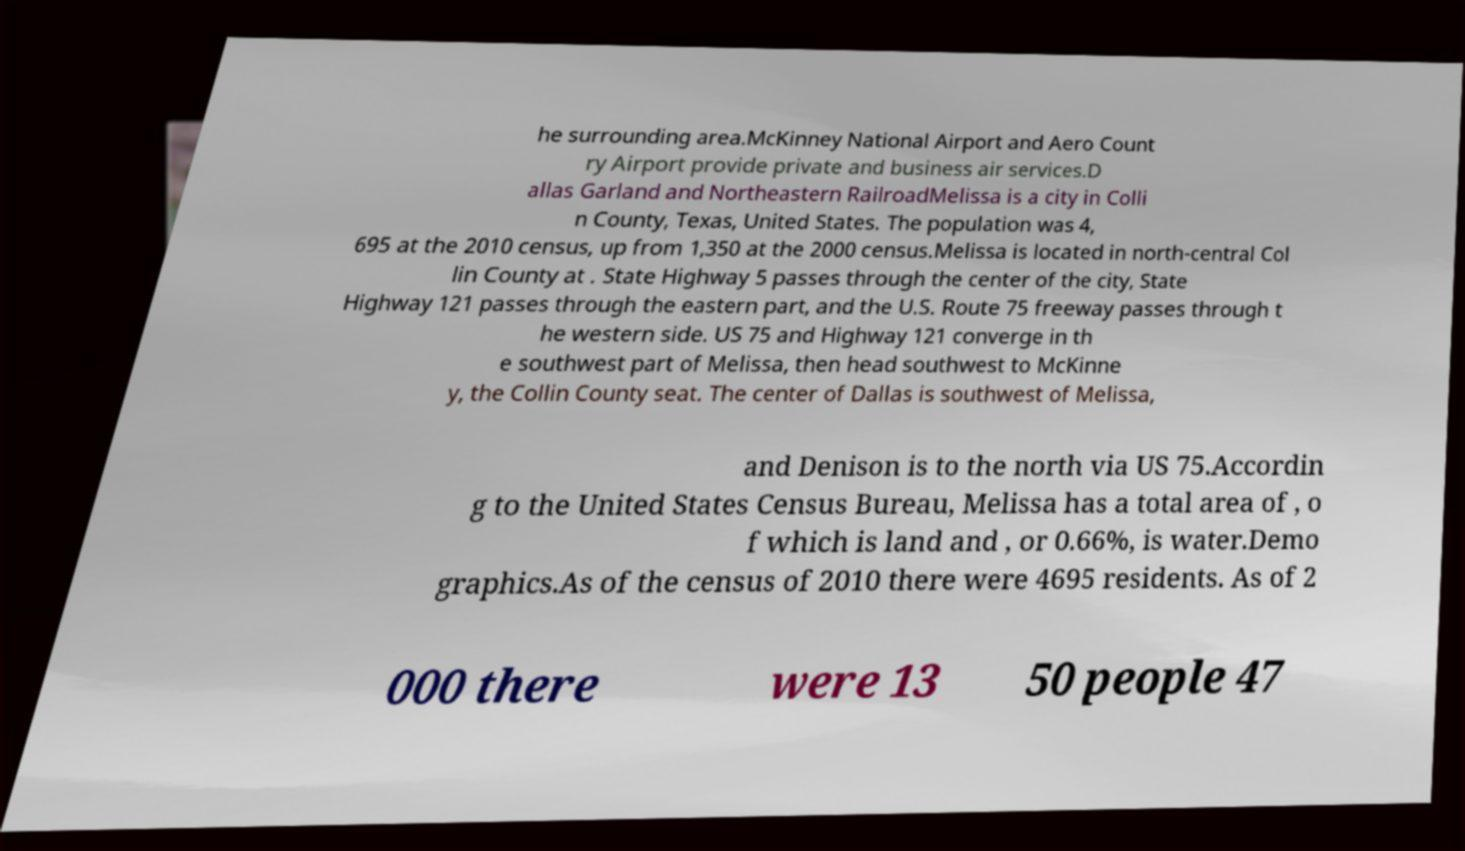Please read and relay the text visible in this image. What does it say? he surrounding area.McKinney National Airport and Aero Count ry Airport provide private and business air services.D allas Garland and Northeastern RailroadMelissa is a city in Colli n County, Texas, United States. The population was 4, 695 at the 2010 census, up from 1,350 at the 2000 census.Melissa is located in north-central Col lin County at . State Highway 5 passes through the center of the city, State Highway 121 passes through the eastern part, and the U.S. Route 75 freeway passes through t he western side. US 75 and Highway 121 converge in th e southwest part of Melissa, then head southwest to McKinne y, the Collin County seat. The center of Dallas is southwest of Melissa, and Denison is to the north via US 75.Accordin g to the United States Census Bureau, Melissa has a total area of , o f which is land and , or 0.66%, is water.Demo graphics.As of the census of 2010 there were 4695 residents. As of 2 000 there were 13 50 people 47 